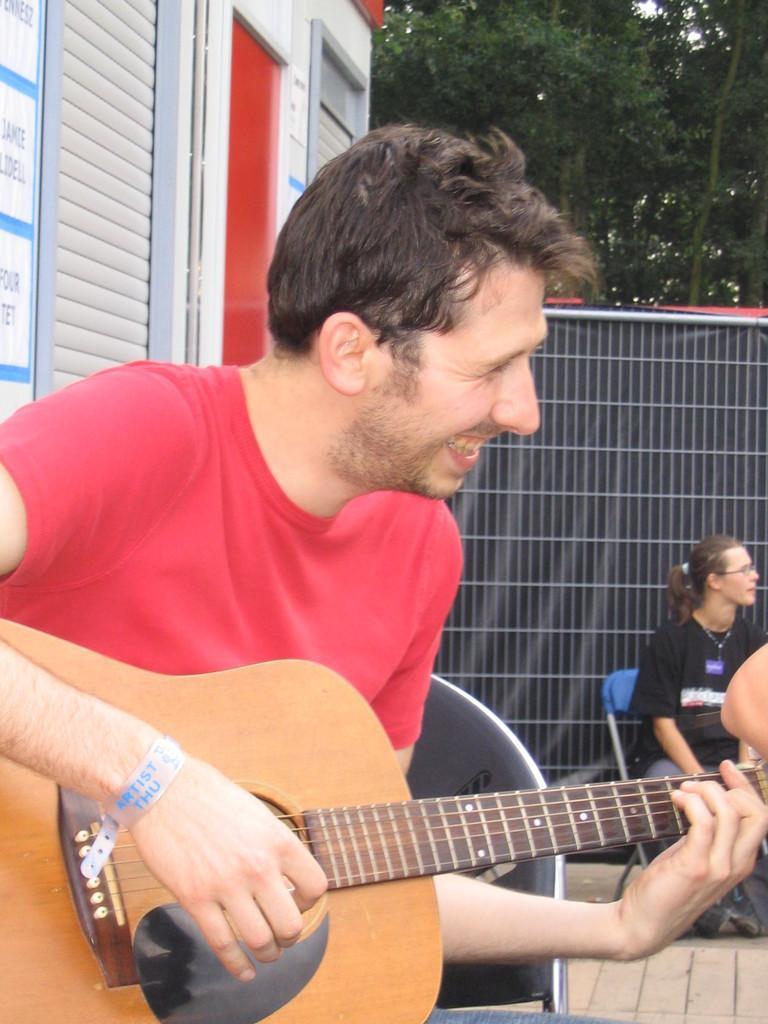Please provide a concise description of this image. In this picture we can see a man who is playing guitar. He is smiling. Here we can see a woman who is sitting on the chair. This is floor and these are the trees. 